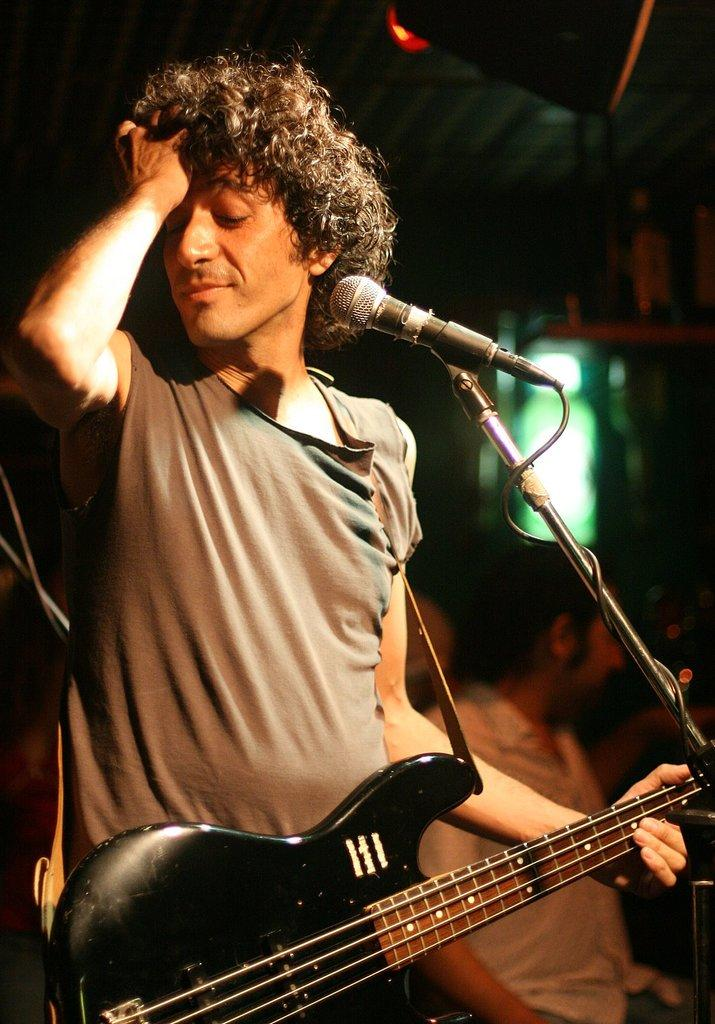What is the person in the image doing? The person is holding a guitar and standing in front of a microphone with a stand. What object is the person holding in the image? The person is holding a guitar. What is the person doing with their hand in the image? The person has their hand on their hair. What type of rail can be seen in the image? There is no rail present in the image. How many bananas are visible in the image? There are no bananas present in the image. 